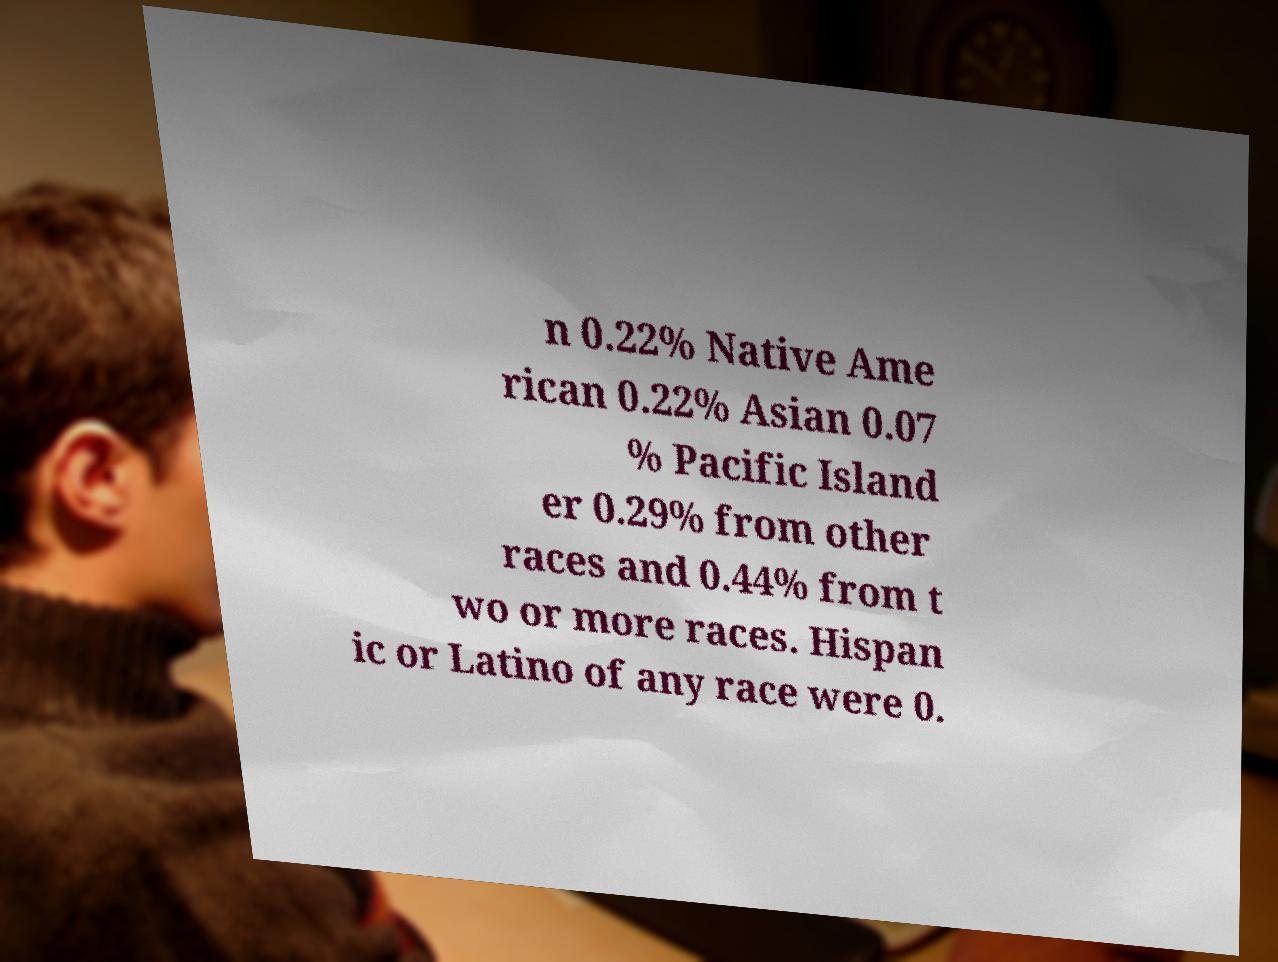Could you extract and type out the text from this image? n 0.22% Native Ame rican 0.22% Asian 0.07 % Pacific Island er 0.29% from other races and 0.44% from t wo or more races. Hispan ic or Latino of any race were 0. 